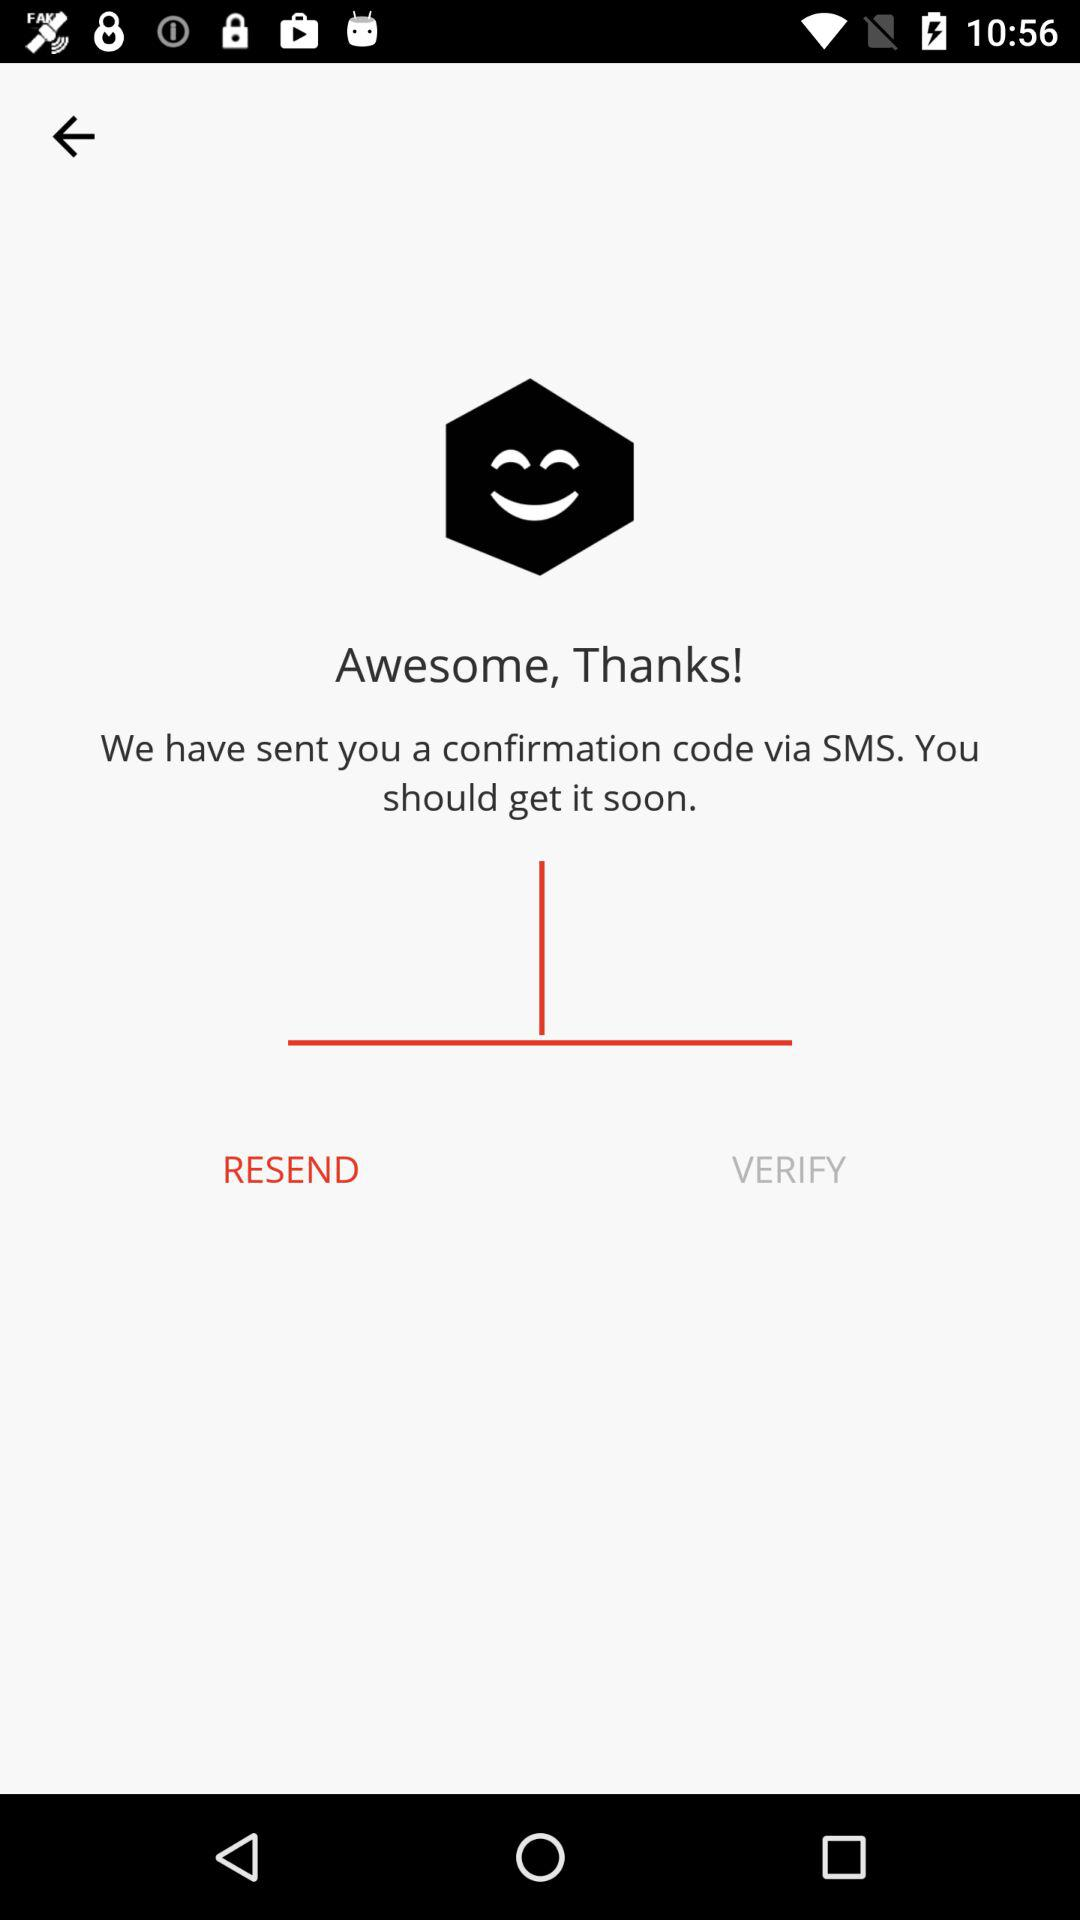What is the name of the application?
When the provided information is insufficient, respond with <no answer>. <no answer> 